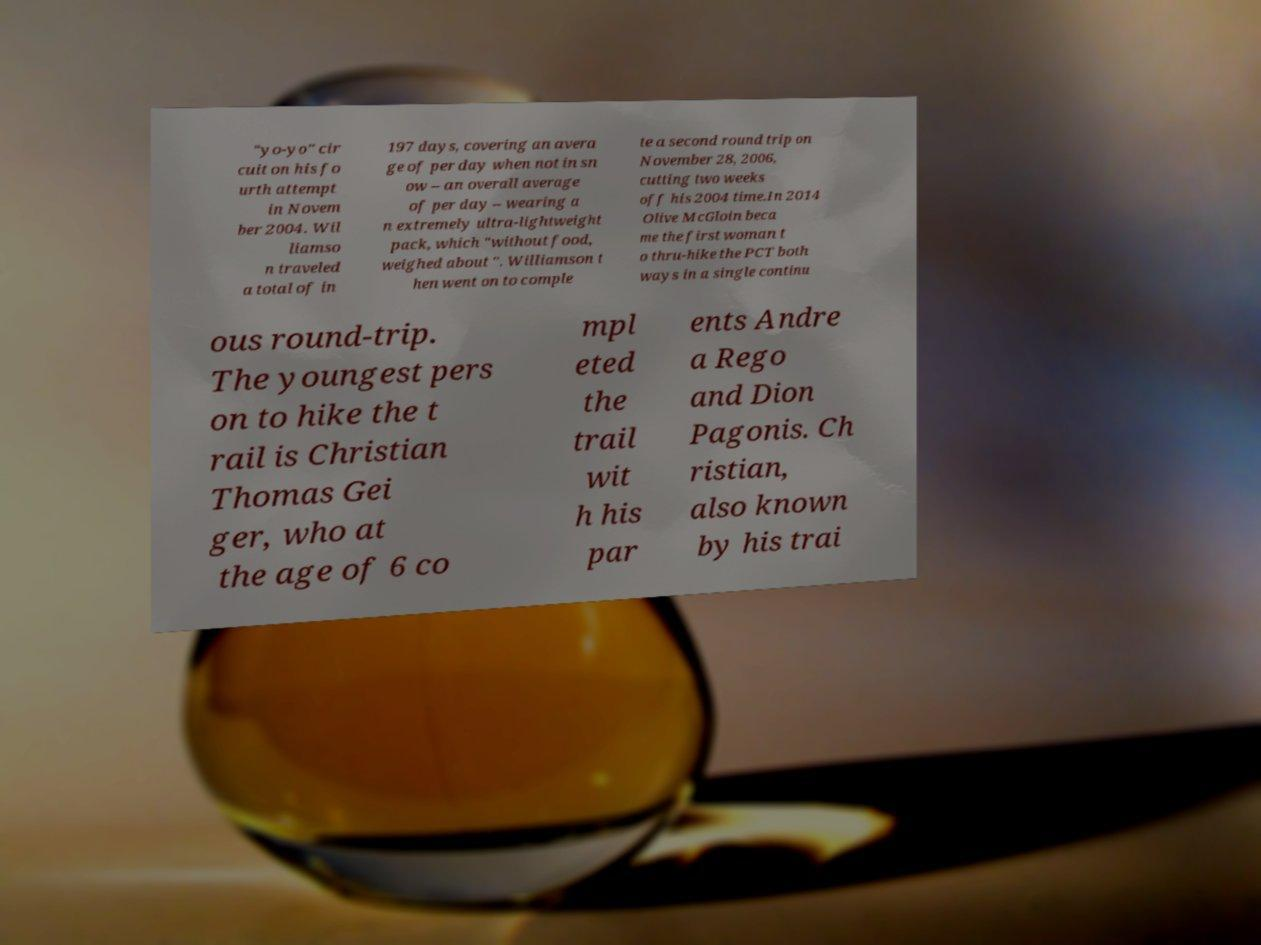Please read and relay the text visible in this image. What does it say? "yo-yo" cir cuit on his fo urth attempt in Novem ber 2004. Wil liamso n traveled a total of in 197 days, covering an avera ge of per day when not in sn ow – an overall average of per day – wearing a n extremely ultra-lightweight pack, which "without food, weighed about ". Williamson t hen went on to comple te a second round trip on November 28, 2006, cutting two weeks off his 2004 time.In 2014 Olive McGloin beca me the first woman t o thru-hike the PCT both ways in a single continu ous round-trip. The youngest pers on to hike the t rail is Christian Thomas Gei ger, who at the age of 6 co mpl eted the trail wit h his par ents Andre a Rego and Dion Pagonis. Ch ristian, also known by his trai 